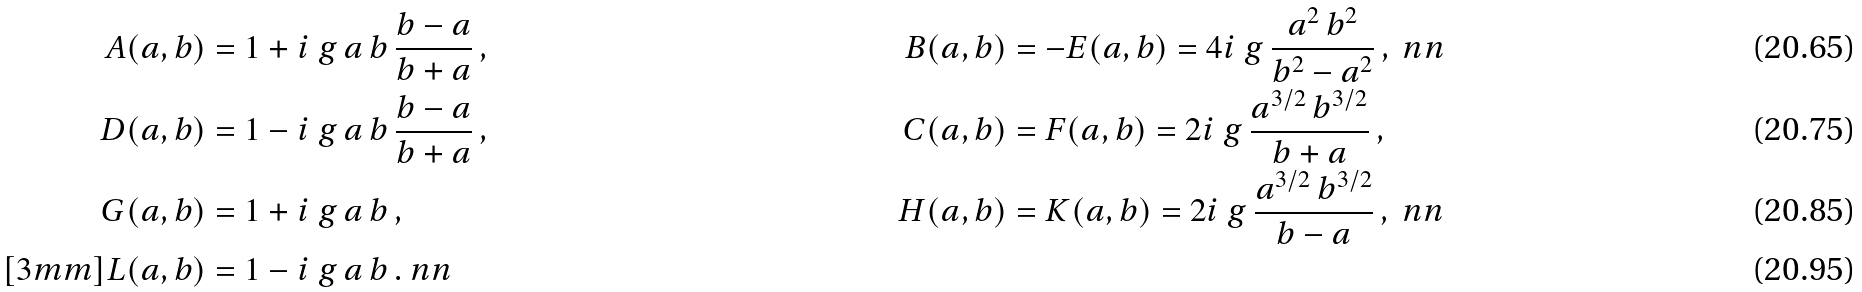<formula> <loc_0><loc_0><loc_500><loc_500>A ( a , b ) & = 1 + i \ g \, a \, b \, \frac { b - a } { b + a } \, , & B ( a , b ) & = - E ( a , b ) = 4 i \ g \, \frac { a ^ { 2 } \, b ^ { 2 } } { b ^ { 2 } - a ^ { 2 } } \, , \ n n \\ D ( a , b ) & = 1 - i \ g \, a \, b \, \frac { b - a } { b + a } \, , & C ( a , b ) & = F ( a , b ) = 2 i \ g \, \frac { a ^ { 3 / 2 } \, b ^ { 3 / 2 } } { b + a } \, , \\ G ( a , b ) & = 1 + i \ g \, a \, b \, , & H ( a , b ) & = K ( a , b ) = 2 i \ g \, \frac { a ^ { 3 / 2 } \, b ^ { 3 / 2 } } { b - a } \, , \ n n \\ [ 3 m m ] L ( a , b ) & = 1 - i \ g \, a \, b \, . \ n n</formula> 